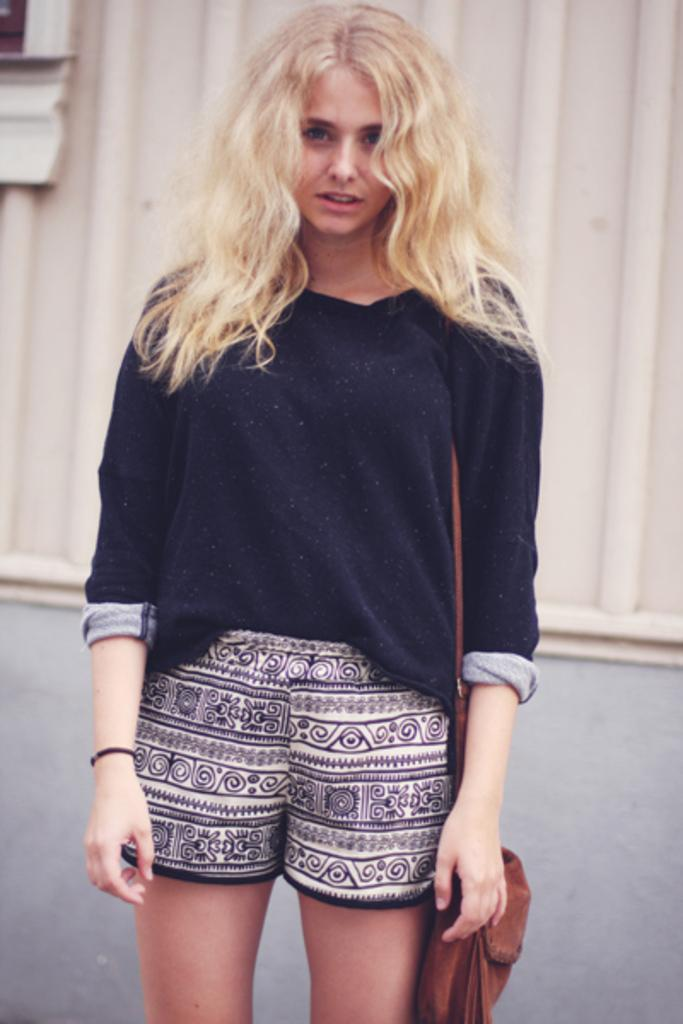Who is present in the image? There is a woman in the image. What is the woman doing in the image? The woman is standing in the image. What is the woman holding or carrying in the image? The woman is carrying a bag in the image. What can be seen in the background of the image? There is a wall in the background of the image. What type of dress is the woman wearing in the image? The provided facts do not mention the type of dress the woman is wearing, so we cannot answer this question definitively. What is the woman using to write notes in the image? There is no notebook or any indication of writing in the image, so we cannot answer this question definitively. 